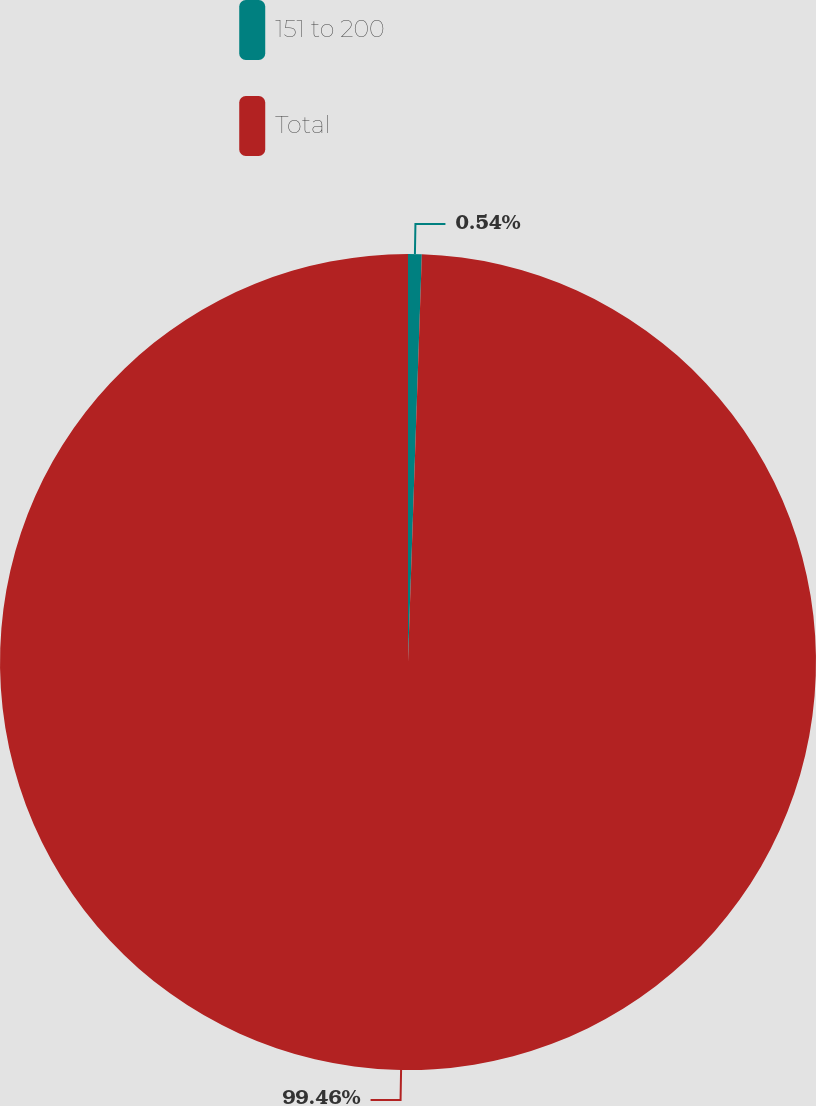<chart> <loc_0><loc_0><loc_500><loc_500><pie_chart><fcel>151 to 200<fcel>Total<nl><fcel>0.54%<fcel>99.46%<nl></chart> 